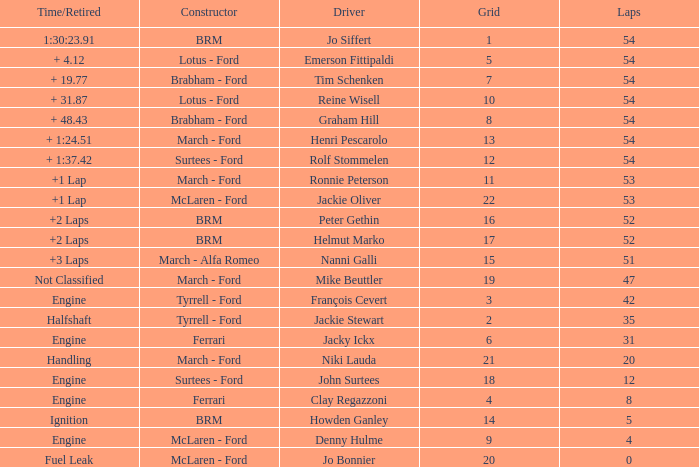What is the average grid that has over 8 laps, a Time/Retired of +2 laps, and peter gethin driving? 16.0. 